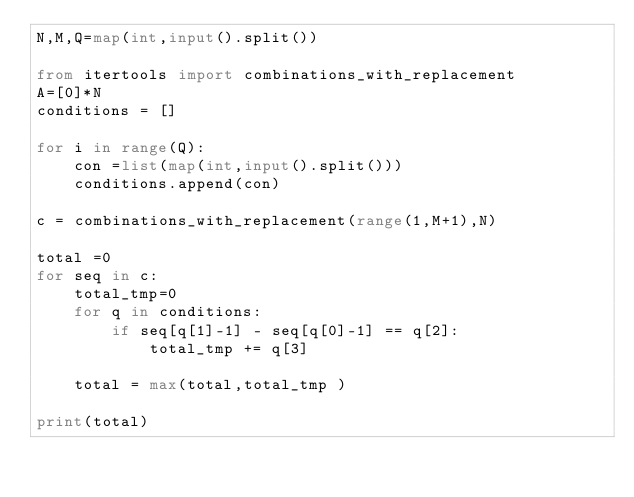Convert code to text. <code><loc_0><loc_0><loc_500><loc_500><_Python_>N,M,Q=map(int,input().split())

from itertools import combinations_with_replacement
A=[0]*N
conditions = []

for i in range(Q):
    con =list(map(int,input().split()))
    conditions.append(con)

c = combinations_with_replacement(range(1,M+1),N)

total =0
for seq in c:
    total_tmp=0
    for q in conditions:
        if seq[q[1]-1] - seq[q[0]-1] == q[2]:
            total_tmp += q[3]

    total = max(total,total_tmp )

print(total)

</code> 